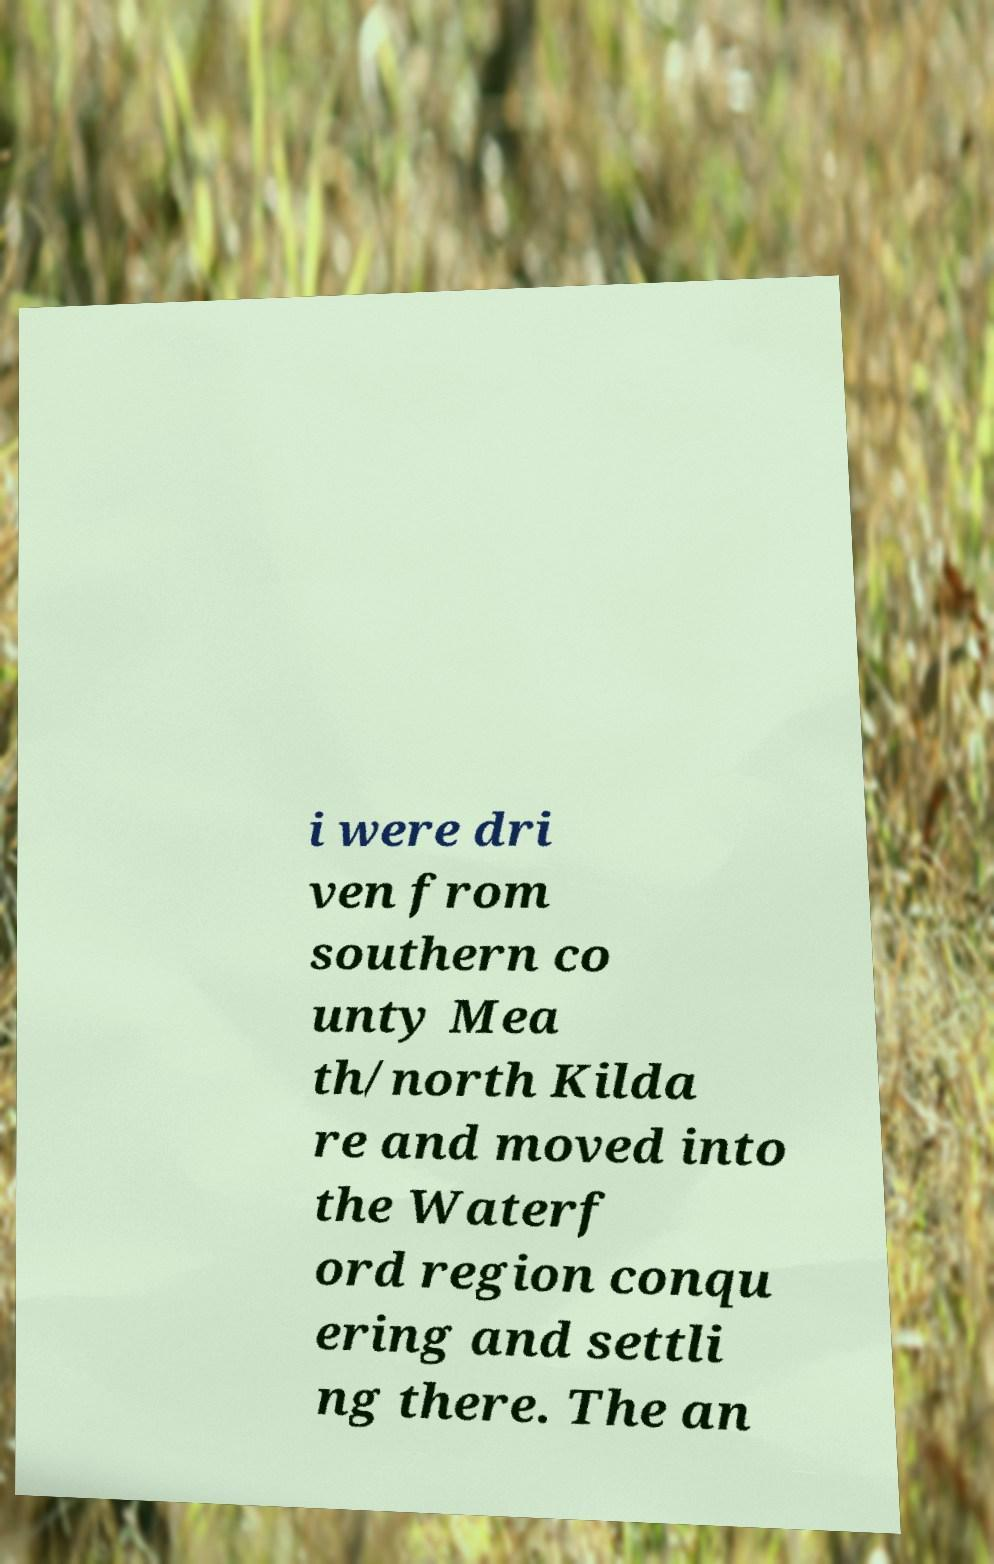For documentation purposes, I need the text within this image transcribed. Could you provide that? i were dri ven from southern co unty Mea th/north Kilda re and moved into the Waterf ord region conqu ering and settli ng there. The an 